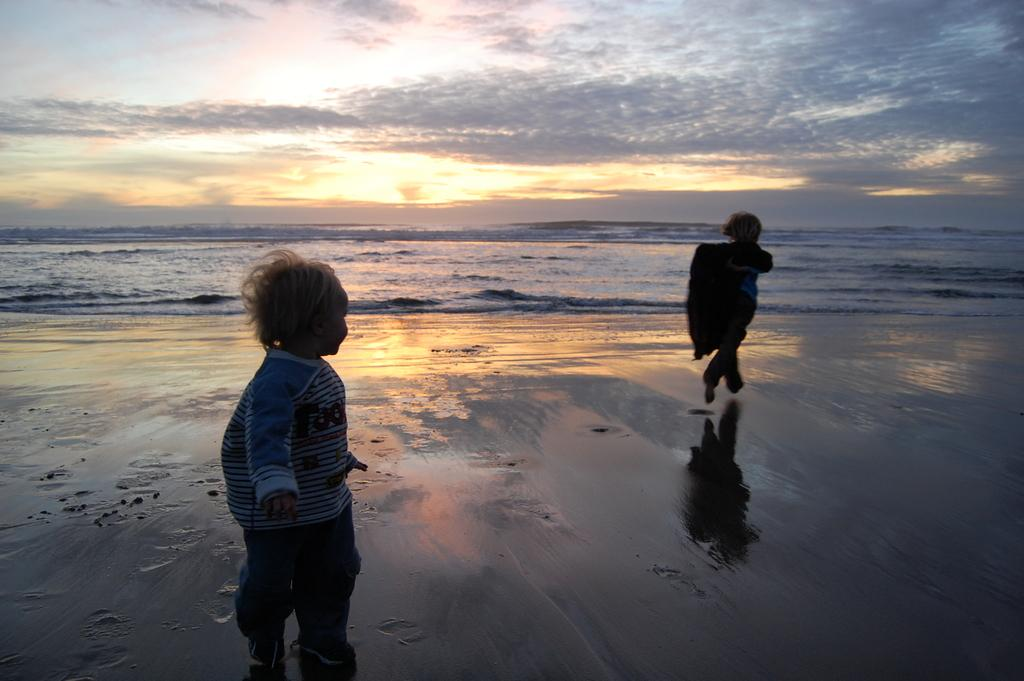How many children are in the image? There are two children in the image. Where are the children located in the image? The children are on the sea shore. What can be seen in the background of the image? There is water and the sky visible in the background of the image. What is the condition of the sky in the image? Clouds are present in the sky. What type of beds can be seen in the image? There are no beds present in the image; it features two children on the sea shore. Is there a bear visible in the image? There is there a bedroom? 